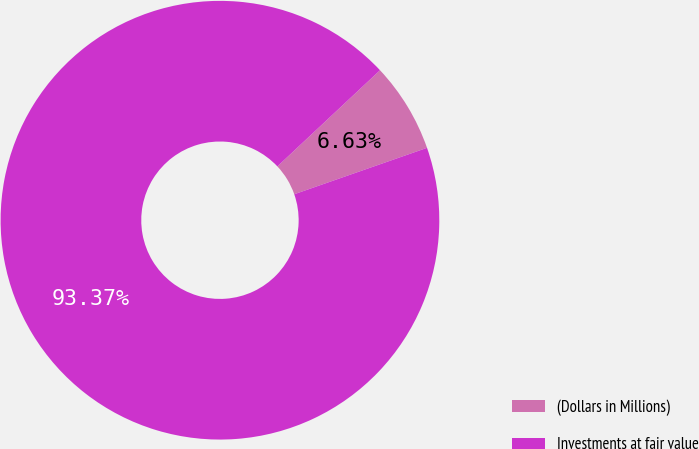<chart> <loc_0><loc_0><loc_500><loc_500><pie_chart><fcel>(Dollars in Millions)<fcel>Investments at fair value<nl><fcel>6.63%<fcel>93.37%<nl></chart> 